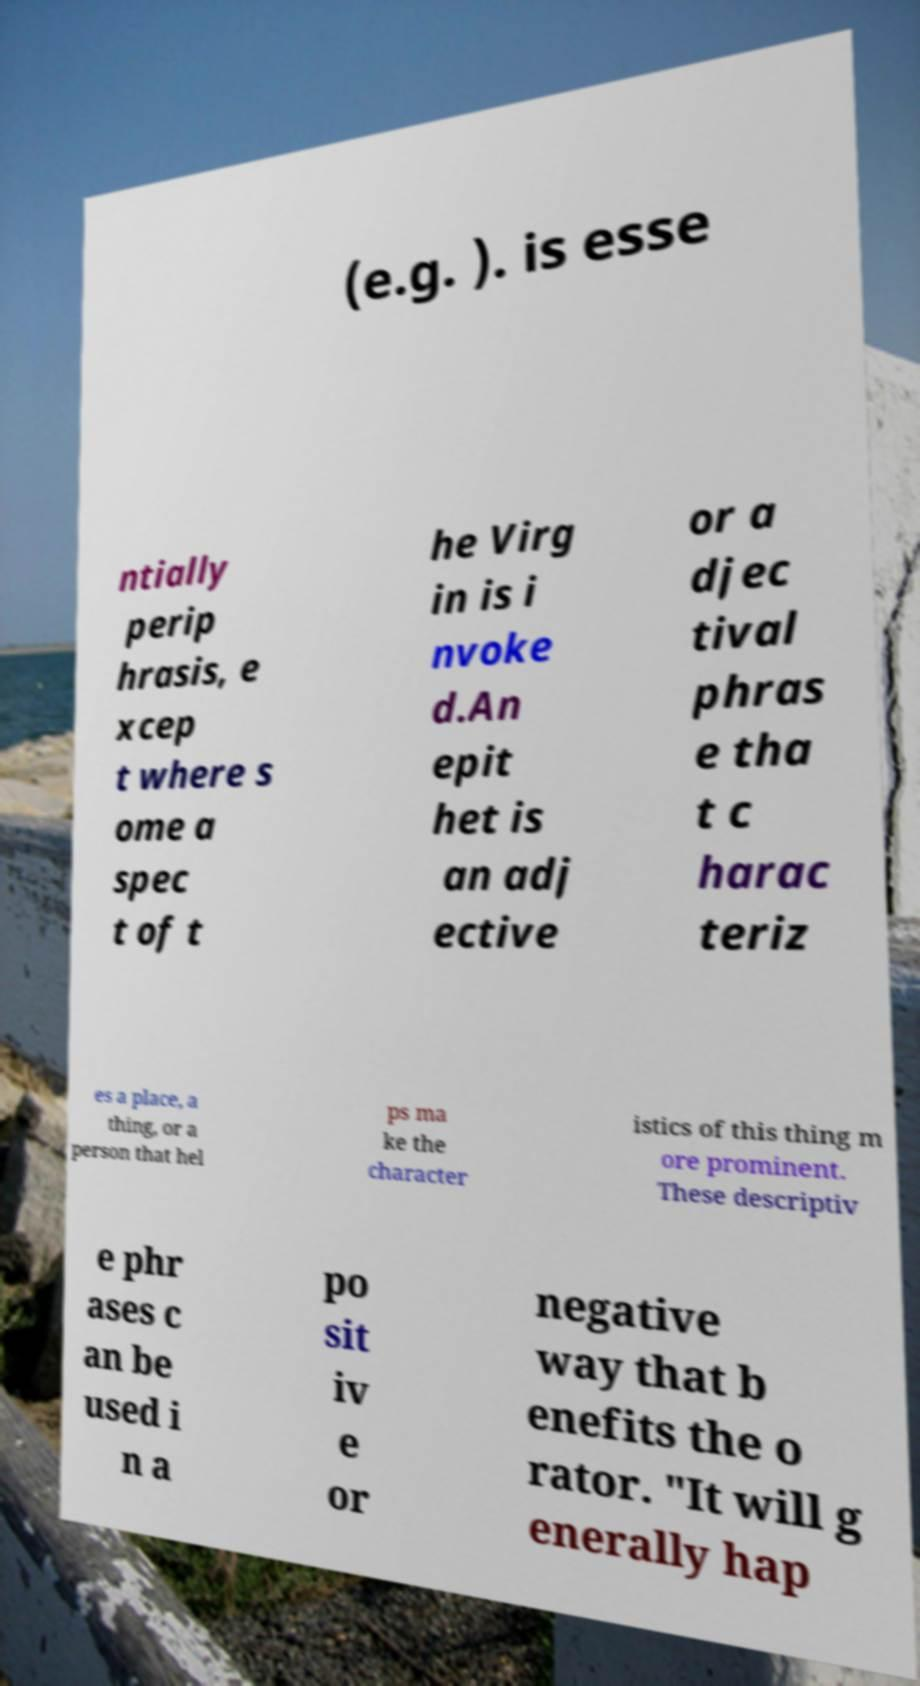There's text embedded in this image that I need extracted. Can you transcribe it verbatim? (e.g. ). is esse ntially perip hrasis, e xcep t where s ome a spec t of t he Virg in is i nvoke d.An epit het is an adj ective or a djec tival phras e tha t c harac teriz es a place, a thing, or a person that hel ps ma ke the character istics of this thing m ore prominent. These descriptiv e phr ases c an be used i n a po sit iv e or negative way that b enefits the o rator. "It will g enerally hap 